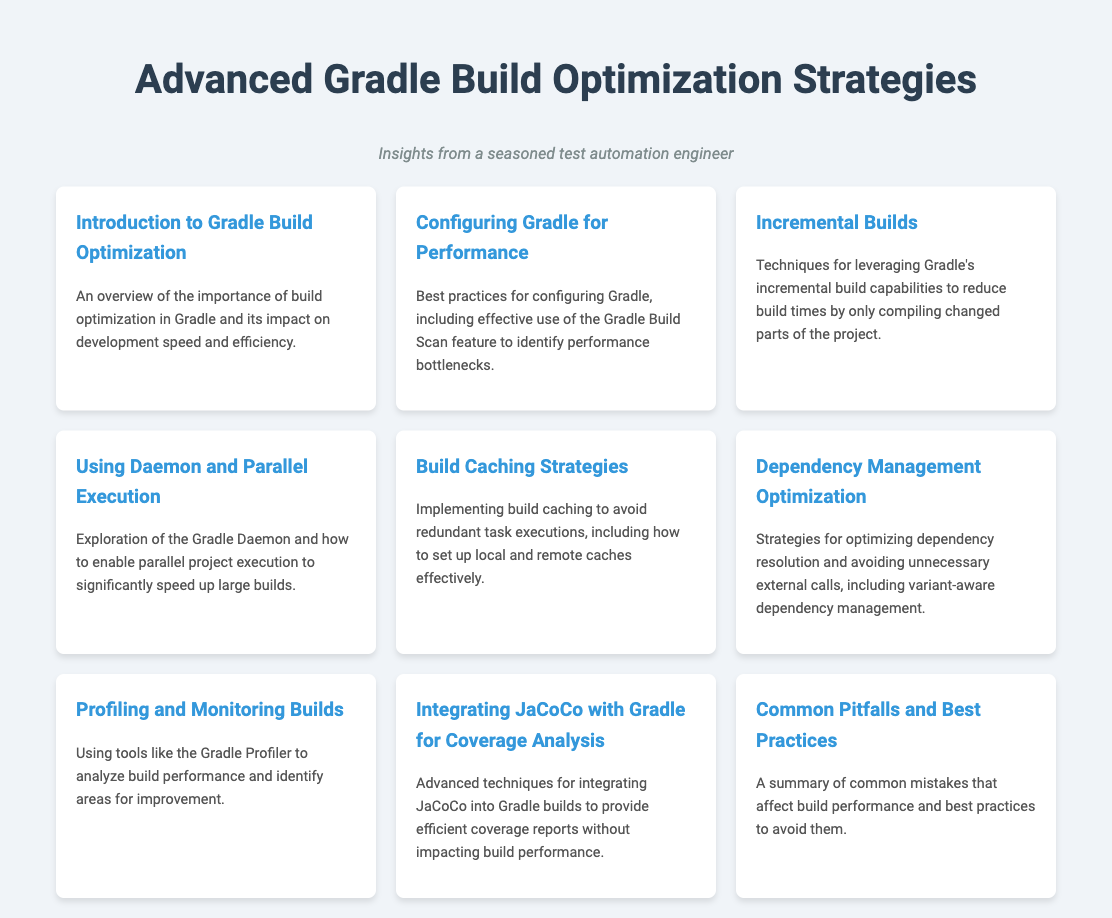What is the title of the document? The title of the document is clearly stated at the top, which is "Advanced Gradle Build Optimization Strategies."
Answer: Advanced Gradle Build Optimization Strategies How many menu items are listed in the document? The document displays a grid of menu items, which can be counted for a total. There are 9 menu items in total.
Answer: 9 What feature is suggested for identifying performance bottlenecks in Gradle? The "Gradle Build Scan feature" is mentioned as a means to identify performance bottlenecks.
Answer: Gradle Build Scan Which section discusses integrating JaCoCo with Gradle? The section titled "Integrating JaCoCo with Gradle for Coverage Analysis" addresses this integration specifically.
Answer: Integrating JaCoCo with Gradle for Coverage Analysis What is a primary strategy to reduce build times in Gradle? "Incremental Builds" is highlighted as a technique for reducing build times by only compiling changed parts.
Answer: Incremental Builds Which menu item focuses on dependency management? The "Dependency Management Optimization" menu item focuses exclusively on this topic.
Answer: Dependency Management Optimization What does the document suggest to avoid redundant task executions? The document recommends "Implementing build caching" to avoid redundant task executions.
Answer: Implementing build caching Which section provides insights into common mistakes? The section titled "Common Pitfalls and Best Practices" gives insights into mistakes affecting build performance.
Answer: Common Pitfalls and Best Practices What is the color theme of the document? The document features primarily a white background with shades of blue and gray for text, which creates a clean look.
Answer: White and shades of blue/gray 